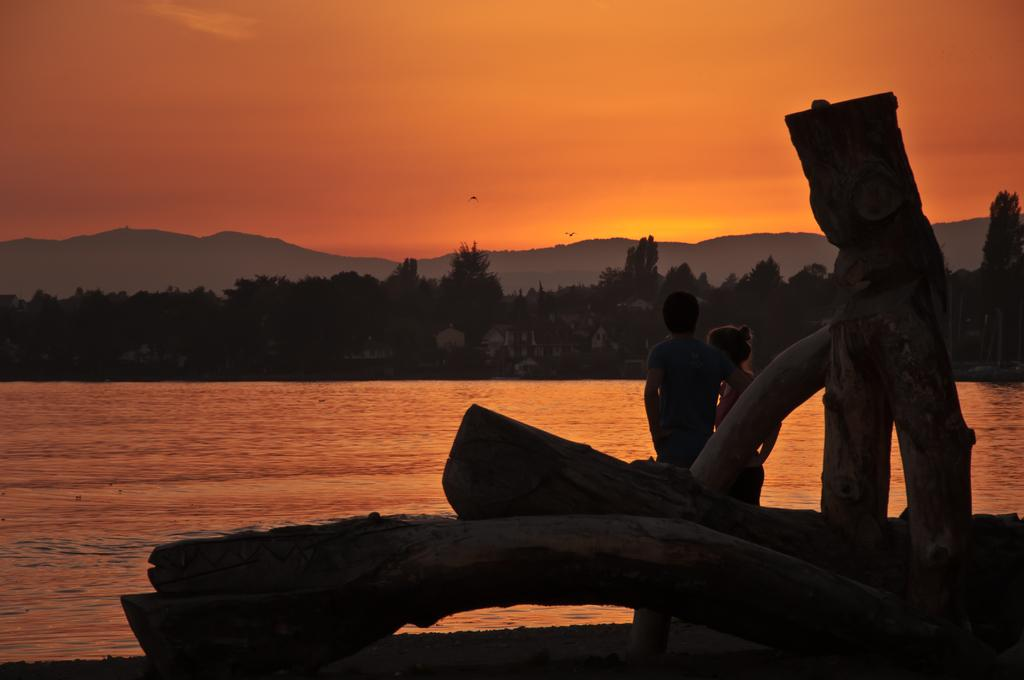What is located in the center of the image? There are tree trunks in the center of the image, and two persons are standing there as well. What can be seen in the background of the image? The sky, trees, buildings, hills, water, and two birds flying are visible in the background of the image. What arithmetic problem are the two persons solving in the image? There is no arithmetic problem visible in the image; it features tree trunks, two persons standing, and various elements in the background. What family members are present in the image? The image does not depict any family members; it only shows two persons standing in the center. 